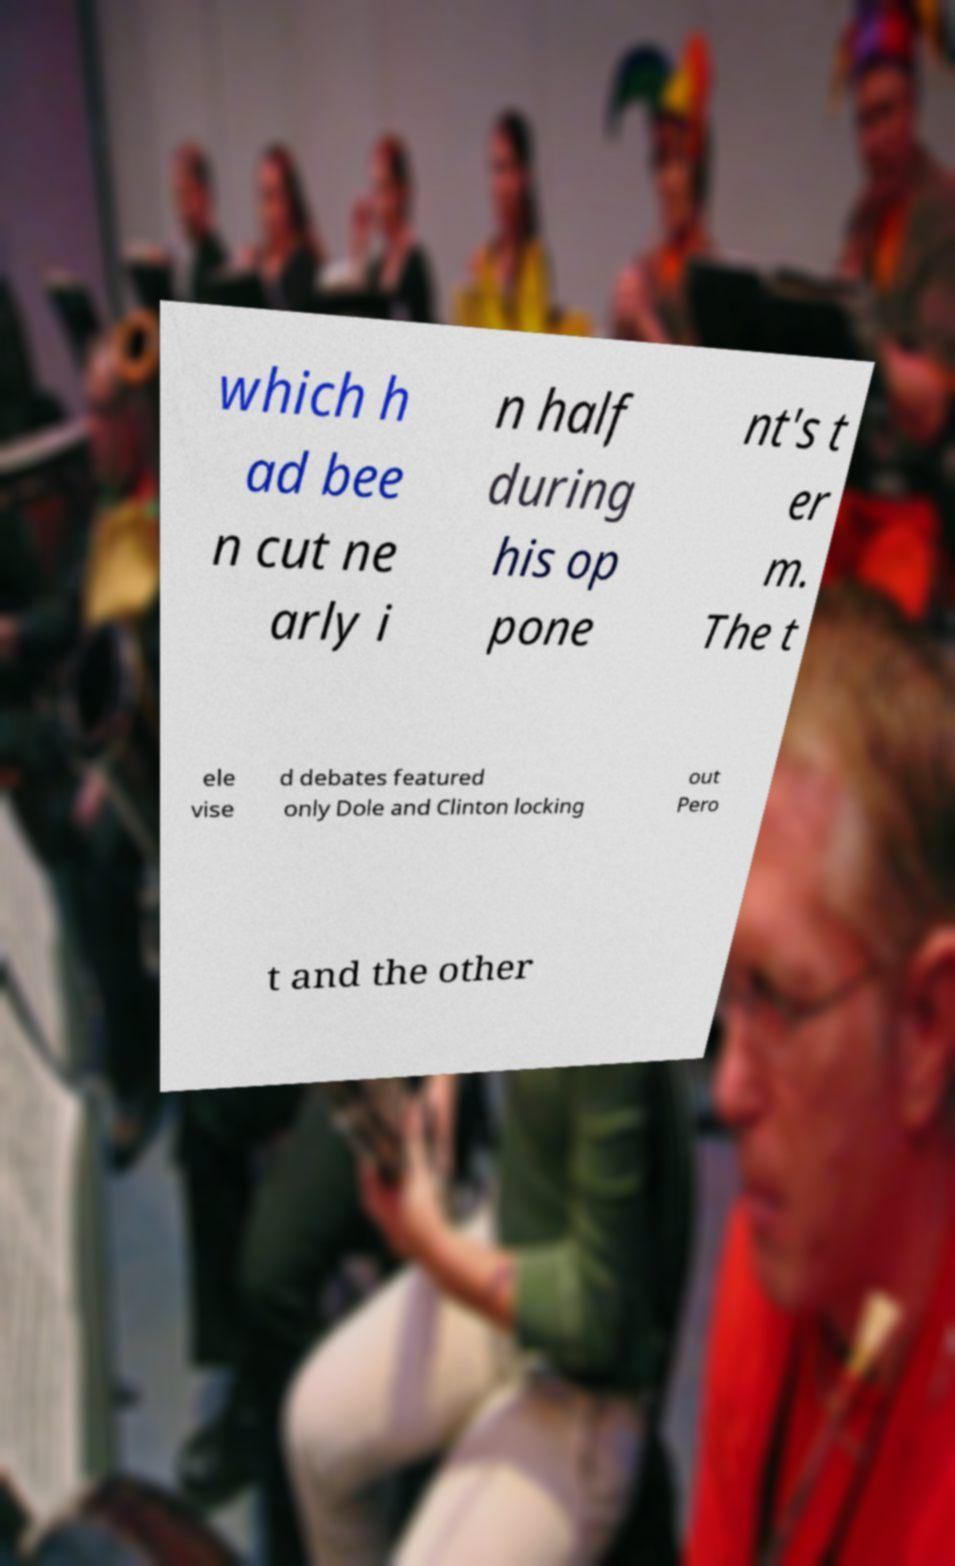Please identify and transcribe the text found in this image. which h ad bee n cut ne arly i n half during his op pone nt's t er m. The t ele vise d debates featured only Dole and Clinton locking out Pero t and the other 